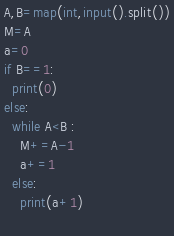<code> <loc_0><loc_0><loc_500><loc_500><_Python_>A,B=map(int,input().split())
M=A
a=0
if B==1:
  print(0)
else:
  while A<B :
    M+=A-1
    a+=1
  else:
    print(a+1)
  </code> 